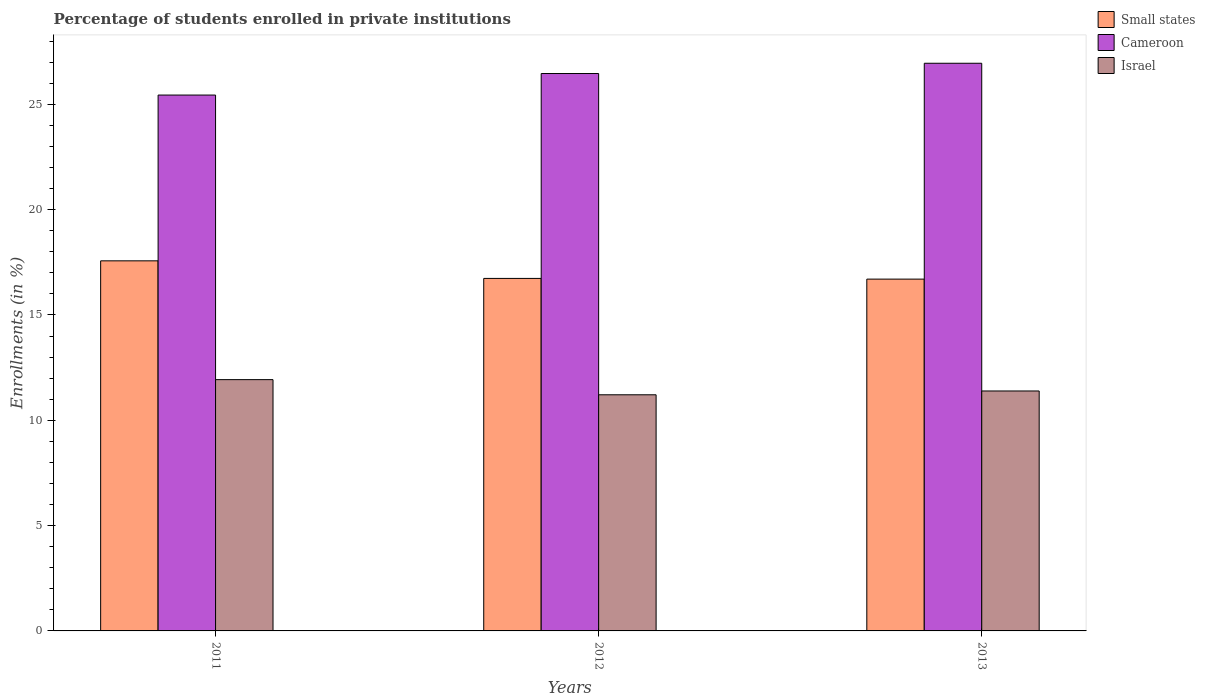How many groups of bars are there?
Your answer should be compact. 3. Are the number of bars per tick equal to the number of legend labels?
Provide a short and direct response. Yes. What is the label of the 1st group of bars from the left?
Make the answer very short. 2011. What is the percentage of trained teachers in Israel in 2013?
Offer a terse response. 11.39. Across all years, what is the maximum percentage of trained teachers in Cameroon?
Your answer should be compact. 26.95. Across all years, what is the minimum percentage of trained teachers in Israel?
Make the answer very short. 11.21. In which year was the percentage of trained teachers in Cameroon minimum?
Ensure brevity in your answer.  2011. What is the total percentage of trained teachers in Israel in the graph?
Provide a short and direct response. 34.53. What is the difference between the percentage of trained teachers in Israel in 2011 and that in 2013?
Ensure brevity in your answer.  0.54. What is the difference between the percentage of trained teachers in Cameroon in 2011 and the percentage of trained teachers in Israel in 2012?
Your answer should be compact. 14.23. What is the average percentage of trained teachers in Cameroon per year?
Your answer should be compact. 26.29. In the year 2011, what is the difference between the percentage of trained teachers in Small states and percentage of trained teachers in Israel?
Give a very brief answer. 5.64. In how many years, is the percentage of trained teachers in Cameroon greater than 6 %?
Make the answer very short. 3. What is the ratio of the percentage of trained teachers in Small states in 2011 to that in 2013?
Offer a terse response. 1.05. Is the percentage of trained teachers in Cameroon in 2012 less than that in 2013?
Your answer should be compact. Yes. Is the difference between the percentage of trained teachers in Small states in 2011 and 2012 greater than the difference between the percentage of trained teachers in Israel in 2011 and 2012?
Your response must be concise. Yes. What is the difference between the highest and the second highest percentage of trained teachers in Cameroon?
Ensure brevity in your answer.  0.49. What is the difference between the highest and the lowest percentage of trained teachers in Small states?
Provide a short and direct response. 0.87. Is the sum of the percentage of trained teachers in Cameroon in 2012 and 2013 greater than the maximum percentage of trained teachers in Israel across all years?
Offer a terse response. Yes. What does the 2nd bar from the right in 2012 represents?
Provide a succinct answer. Cameroon. Is it the case that in every year, the sum of the percentage of trained teachers in Small states and percentage of trained teachers in Cameroon is greater than the percentage of trained teachers in Israel?
Your response must be concise. Yes. How many bars are there?
Offer a terse response. 9. Are all the bars in the graph horizontal?
Provide a short and direct response. No. What is the title of the graph?
Your answer should be compact. Percentage of students enrolled in private institutions. What is the label or title of the Y-axis?
Offer a terse response. Enrollments (in %). What is the Enrollments (in %) of Small states in 2011?
Offer a terse response. 17.57. What is the Enrollments (in %) in Cameroon in 2011?
Your response must be concise. 25.44. What is the Enrollments (in %) in Israel in 2011?
Make the answer very short. 11.93. What is the Enrollments (in %) in Small states in 2012?
Offer a terse response. 16.74. What is the Enrollments (in %) in Cameroon in 2012?
Make the answer very short. 26.46. What is the Enrollments (in %) in Israel in 2012?
Offer a terse response. 11.21. What is the Enrollments (in %) of Small states in 2013?
Provide a short and direct response. 16.7. What is the Enrollments (in %) of Cameroon in 2013?
Offer a terse response. 26.95. What is the Enrollments (in %) in Israel in 2013?
Your response must be concise. 11.39. Across all years, what is the maximum Enrollments (in %) in Small states?
Keep it short and to the point. 17.57. Across all years, what is the maximum Enrollments (in %) of Cameroon?
Provide a succinct answer. 26.95. Across all years, what is the maximum Enrollments (in %) in Israel?
Your response must be concise. 11.93. Across all years, what is the minimum Enrollments (in %) of Small states?
Give a very brief answer. 16.7. Across all years, what is the minimum Enrollments (in %) of Cameroon?
Give a very brief answer. 25.44. Across all years, what is the minimum Enrollments (in %) of Israel?
Offer a very short reply. 11.21. What is the total Enrollments (in %) in Small states in the graph?
Your response must be concise. 51.01. What is the total Enrollments (in %) in Cameroon in the graph?
Keep it short and to the point. 78.86. What is the total Enrollments (in %) in Israel in the graph?
Offer a very short reply. 34.53. What is the difference between the Enrollments (in %) in Small states in 2011 and that in 2012?
Your response must be concise. 0.83. What is the difference between the Enrollments (in %) of Cameroon in 2011 and that in 2012?
Give a very brief answer. -1.02. What is the difference between the Enrollments (in %) in Israel in 2011 and that in 2012?
Give a very brief answer. 0.72. What is the difference between the Enrollments (in %) in Small states in 2011 and that in 2013?
Keep it short and to the point. 0.87. What is the difference between the Enrollments (in %) in Cameroon in 2011 and that in 2013?
Provide a short and direct response. -1.51. What is the difference between the Enrollments (in %) of Israel in 2011 and that in 2013?
Keep it short and to the point. 0.54. What is the difference between the Enrollments (in %) of Small states in 2012 and that in 2013?
Offer a terse response. 0.03. What is the difference between the Enrollments (in %) in Cameroon in 2012 and that in 2013?
Your answer should be very brief. -0.49. What is the difference between the Enrollments (in %) in Israel in 2012 and that in 2013?
Your answer should be very brief. -0.18. What is the difference between the Enrollments (in %) in Small states in 2011 and the Enrollments (in %) in Cameroon in 2012?
Give a very brief answer. -8.89. What is the difference between the Enrollments (in %) in Small states in 2011 and the Enrollments (in %) in Israel in 2012?
Give a very brief answer. 6.36. What is the difference between the Enrollments (in %) of Cameroon in 2011 and the Enrollments (in %) of Israel in 2012?
Provide a short and direct response. 14.23. What is the difference between the Enrollments (in %) of Small states in 2011 and the Enrollments (in %) of Cameroon in 2013?
Offer a very short reply. -9.38. What is the difference between the Enrollments (in %) in Small states in 2011 and the Enrollments (in %) in Israel in 2013?
Your answer should be very brief. 6.18. What is the difference between the Enrollments (in %) in Cameroon in 2011 and the Enrollments (in %) in Israel in 2013?
Offer a very short reply. 14.05. What is the difference between the Enrollments (in %) of Small states in 2012 and the Enrollments (in %) of Cameroon in 2013?
Offer a very short reply. -10.21. What is the difference between the Enrollments (in %) in Small states in 2012 and the Enrollments (in %) in Israel in 2013?
Provide a succinct answer. 5.34. What is the difference between the Enrollments (in %) in Cameroon in 2012 and the Enrollments (in %) in Israel in 2013?
Provide a short and direct response. 15.07. What is the average Enrollments (in %) of Small states per year?
Your answer should be very brief. 17. What is the average Enrollments (in %) of Cameroon per year?
Give a very brief answer. 26.29. What is the average Enrollments (in %) in Israel per year?
Make the answer very short. 11.51. In the year 2011, what is the difference between the Enrollments (in %) of Small states and Enrollments (in %) of Cameroon?
Provide a succinct answer. -7.87. In the year 2011, what is the difference between the Enrollments (in %) in Small states and Enrollments (in %) in Israel?
Keep it short and to the point. 5.64. In the year 2011, what is the difference between the Enrollments (in %) of Cameroon and Enrollments (in %) of Israel?
Your answer should be very brief. 13.51. In the year 2012, what is the difference between the Enrollments (in %) of Small states and Enrollments (in %) of Cameroon?
Make the answer very short. -9.73. In the year 2012, what is the difference between the Enrollments (in %) in Small states and Enrollments (in %) in Israel?
Give a very brief answer. 5.53. In the year 2012, what is the difference between the Enrollments (in %) of Cameroon and Enrollments (in %) of Israel?
Offer a terse response. 15.25. In the year 2013, what is the difference between the Enrollments (in %) of Small states and Enrollments (in %) of Cameroon?
Offer a very short reply. -10.25. In the year 2013, what is the difference between the Enrollments (in %) of Small states and Enrollments (in %) of Israel?
Provide a short and direct response. 5.31. In the year 2013, what is the difference between the Enrollments (in %) in Cameroon and Enrollments (in %) in Israel?
Give a very brief answer. 15.56. What is the ratio of the Enrollments (in %) of Small states in 2011 to that in 2012?
Keep it short and to the point. 1.05. What is the ratio of the Enrollments (in %) in Cameroon in 2011 to that in 2012?
Give a very brief answer. 0.96. What is the ratio of the Enrollments (in %) in Israel in 2011 to that in 2012?
Provide a short and direct response. 1.06. What is the ratio of the Enrollments (in %) of Small states in 2011 to that in 2013?
Provide a succinct answer. 1.05. What is the ratio of the Enrollments (in %) in Cameroon in 2011 to that in 2013?
Offer a very short reply. 0.94. What is the ratio of the Enrollments (in %) of Israel in 2011 to that in 2013?
Offer a terse response. 1.05. What is the ratio of the Enrollments (in %) in Small states in 2012 to that in 2013?
Give a very brief answer. 1. What is the ratio of the Enrollments (in %) of Cameroon in 2012 to that in 2013?
Ensure brevity in your answer.  0.98. What is the ratio of the Enrollments (in %) in Israel in 2012 to that in 2013?
Keep it short and to the point. 0.98. What is the difference between the highest and the second highest Enrollments (in %) in Small states?
Offer a terse response. 0.83. What is the difference between the highest and the second highest Enrollments (in %) in Cameroon?
Your answer should be compact. 0.49. What is the difference between the highest and the second highest Enrollments (in %) of Israel?
Provide a short and direct response. 0.54. What is the difference between the highest and the lowest Enrollments (in %) in Small states?
Keep it short and to the point. 0.87. What is the difference between the highest and the lowest Enrollments (in %) in Cameroon?
Offer a very short reply. 1.51. What is the difference between the highest and the lowest Enrollments (in %) of Israel?
Your answer should be very brief. 0.72. 